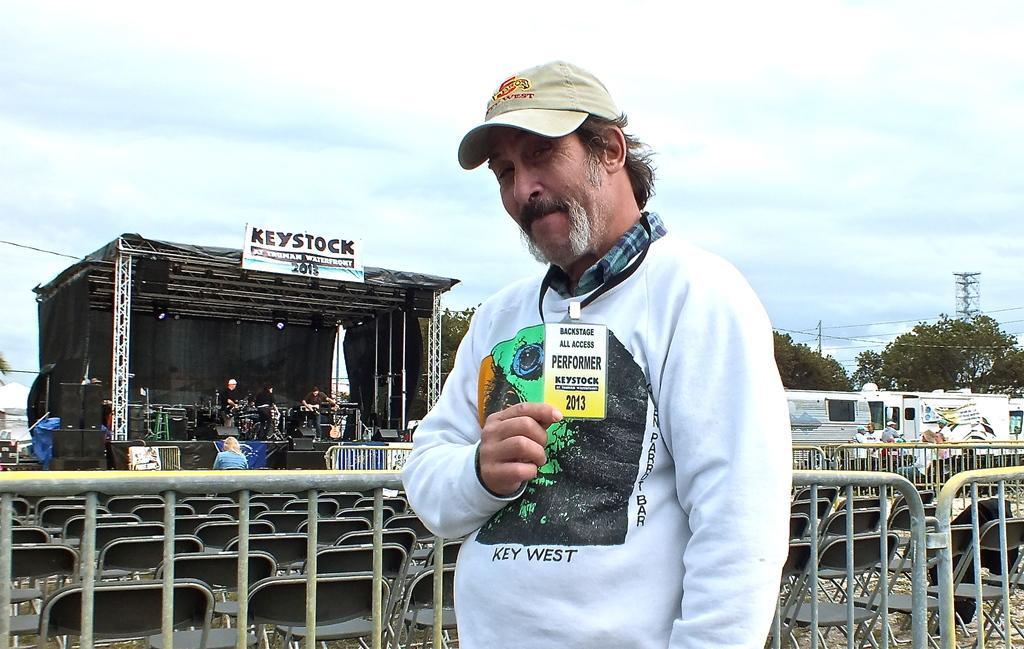Please provide a concise description of this image. In this image we can see a person holding a card and posing for a photo and we can see barricades behind the person. There are some empty chairs and we can see a few people in the background and there is a stage and we can see few people holding musical instruments and there are some objects on the stage. There are some trees and vehicles and at the top we can see the sky. 